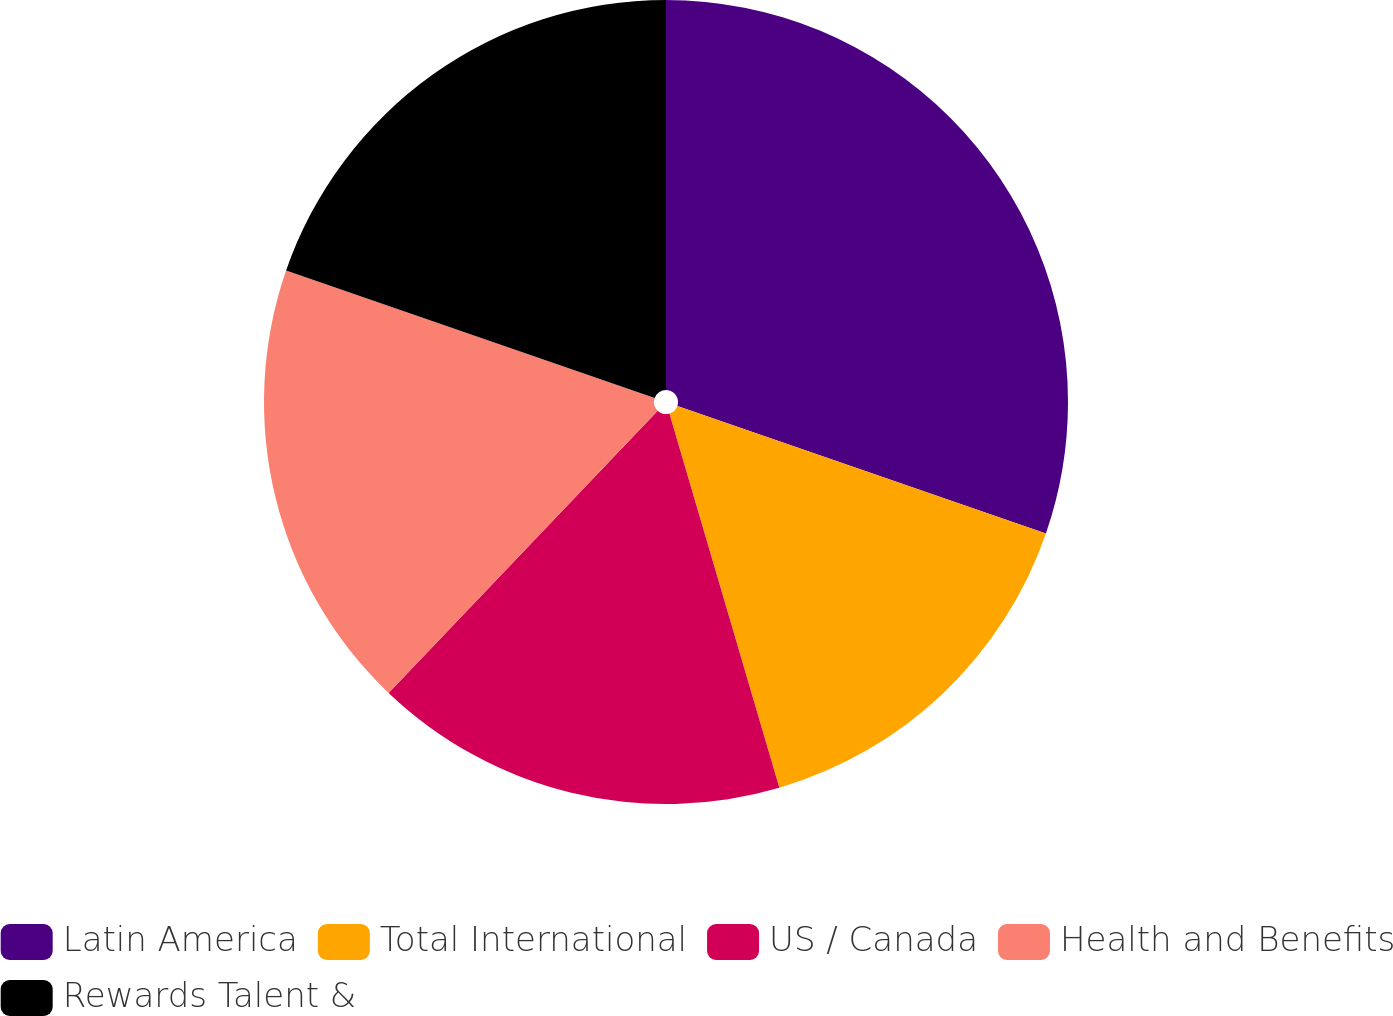Convert chart. <chart><loc_0><loc_0><loc_500><loc_500><pie_chart><fcel>Latin America<fcel>Total International<fcel>US / Canada<fcel>Health and Benefits<fcel>Rewards Talent &<nl><fcel>30.3%<fcel>15.15%<fcel>16.67%<fcel>18.18%<fcel>19.7%<nl></chart> 